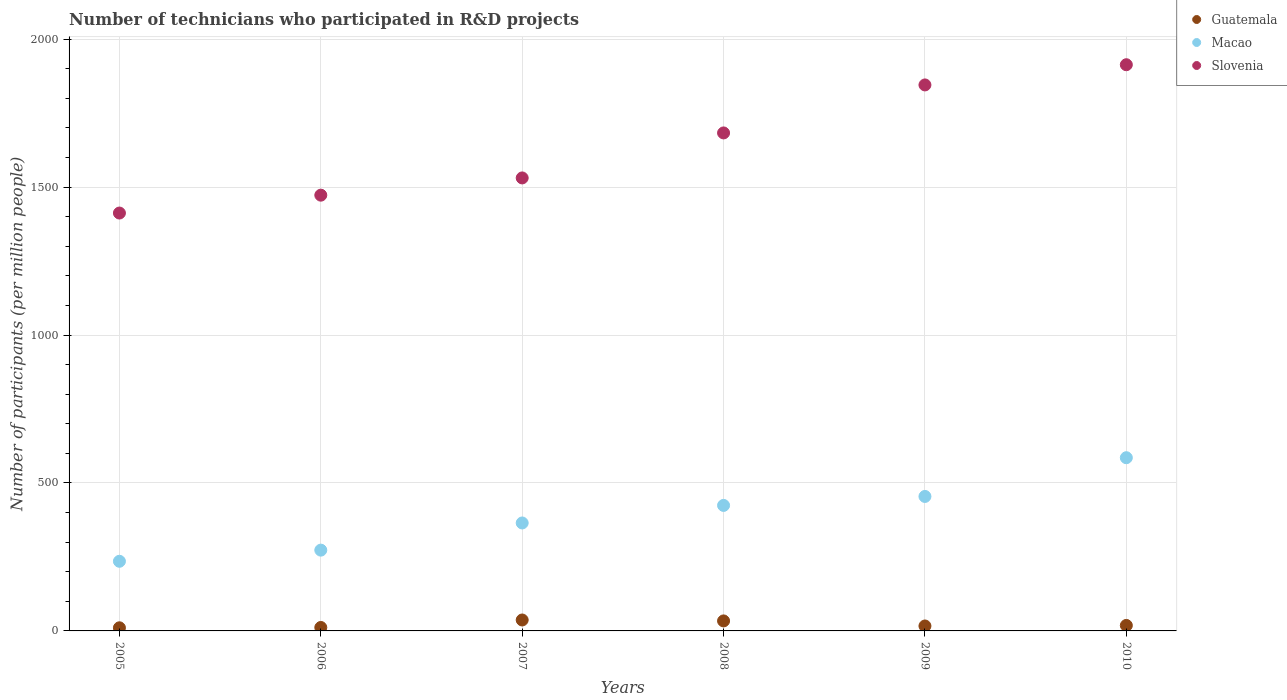What is the number of technicians who participated in R&D projects in Slovenia in 2006?
Provide a succinct answer. 1472.9. Across all years, what is the maximum number of technicians who participated in R&D projects in Macao?
Your response must be concise. 585.46. Across all years, what is the minimum number of technicians who participated in R&D projects in Slovenia?
Your answer should be very brief. 1412.46. In which year was the number of technicians who participated in R&D projects in Macao maximum?
Provide a short and direct response. 2010. In which year was the number of technicians who participated in R&D projects in Guatemala minimum?
Your answer should be compact. 2005. What is the total number of technicians who participated in R&D projects in Slovenia in the graph?
Provide a succinct answer. 9859.03. What is the difference between the number of technicians who participated in R&D projects in Guatemala in 2005 and that in 2010?
Offer a very short reply. -7.99. What is the difference between the number of technicians who participated in R&D projects in Guatemala in 2006 and the number of technicians who participated in R&D projects in Macao in 2009?
Make the answer very short. -442.9. What is the average number of technicians who participated in R&D projects in Macao per year?
Offer a terse response. 389.6. In the year 2010, what is the difference between the number of technicians who participated in R&D projects in Guatemala and number of technicians who participated in R&D projects in Slovenia?
Your response must be concise. -1895.25. What is the ratio of the number of technicians who participated in R&D projects in Macao in 2006 to that in 2010?
Your response must be concise. 0.47. What is the difference between the highest and the second highest number of technicians who participated in R&D projects in Slovenia?
Ensure brevity in your answer.  68.28. What is the difference between the highest and the lowest number of technicians who participated in R&D projects in Guatemala?
Your answer should be compact. 26.42. Is the sum of the number of technicians who participated in R&D projects in Macao in 2007 and 2010 greater than the maximum number of technicians who participated in R&D projects in Slovenia across all years?
Your response must be concise. No. Does the number of technicians who participated in R&D projects in Macao monotonically increase over the years?
Provide a succinct answer. Yes. Is the number of technicians who participated in R&D projects in Guatemala strictly greater than the number of technicians who participated in R&D projects in Macao over the years?
Offer a terse response. No. Is the number of technicians who participated in R&D projects in Slovenia strictly less than the number of technicians who participated in R&D projects in Macao over the years?
Make the answer very short. No. How many dotlines are there?
Ensure brevity in your answer.  3. Does the graph contain any zero values?
Keep it short and to the point. No. Does the graph contain grids?
Give a very brief answer. Yes. How many legend labels are there?
Your answer should be compact. 3. What is the title of the graph?
Provide a short and direct response. Number of technicians who participated in R&D projects. What is the label or title of the X-axis?
Offer a terse response. Years. What is the label or title of the Y-axis?
Offer a terse response. Number of participants (per million people). What is the Number of participants (per million people) in Guatemala in 2005?
Keep it short and to the point. 10.54. What is the Number of participants (per million people) in Macao in 2005?
Your answer should be very brief. 235.4. What is the Number of participants (per million people) in Slovenia in 2005?
Provide a short and direct response. 1412.46. What is the Number of participants (per million people) in Guatemala in 2006?
Give a very brief answer. 11.64. What is the Number of participants (per million people) of Macao in 2006?
Ensure brevity in your answer.  273.07. What is the Number of participants (per million people) in Slovenia in 2006?
Offer a terse response. 1472.9. What is the Number of participants (per million people) of Guatemala in 2007?
Offer a terse response. 36.96. What is the Number of participants (per million people) in Macao in 2007?
Offer a terse response. 364.89. What is the Number of participants (per million people) in Slovenia in 2007?
Your response must be concise. 1531.14. What is the Number of participants (per million people) of Guatemala in 2008?
Give a very brief answer. 33.81. What is the Number of participants (per million people) of Macao in 2008?
Your response must be concise. 424.23. What is the Number of participants (per million people) in Slovenia in 2008?
Keep it short and to the point. 1683.25. What is the Number of participants (per million people) of Guatemala in 2009?
Keep it short and to the point. 16.72. What is the Number of participants (per million people) of Macao in 2009?
Your response must be concise. 454.54. What is the Number of participants (per million people) of Slovenia in 2009?
Give a very brief answer. 1845.5. What is the Number of participants (per million people) of Guatemala in 2010?
Offer a very short reply. 18.53. What is the Number of participants (per million people) in Macao in 2010?
Make the answer very short. 585.46. What is the Number of participants (per million people) in Slovenia in 2010?
Your answer should be compact. 1913.78. Across all years, what is the maximum Number of participants (per million people) of Guatemala?
Offer a terse response. 36.96. Across all years, what is the maximum Number of participants (per million people) in Macao?
Provide a short and direct response. 585.46. Across all years, what is the maximum Number of participants (per million people) of Slovenia?
Your answer should be compact. 1913.78. Across all years, what is the minimum Number of participants (per million people) in Guatemala?
Give a very brief answer. 10.54. Across all years, what is the minimum Number of participants (per million people) of Macao?
Offer a terse response. 235.4. Across all years, what is the minimum Number of participants (per million people) of Slovenia?
Ensure brevity in your answer.  1412.46. What is the total Number of participants (per million people) of Guatemala in the graph?
Give a very brief answer. 128.2. What is the total Number of participants (per million people) in Macao in the graph?
Give a very brief answer. 2337.58. What is the total Number of participants (per million people) in Slovenia in the graph?
Your answer should be compact. 9859.03. What is the difference between the Number of participants (per million people) in Guatemala in 2005 and that in 2006?
Keep it short and to the point. -1.09. What is the difference between the Number of participants (per million people) in Macao in 2005 and that in 2006?
Your answer should be very brief. -37.68. What is the difference between the Number of participants (per million people) in Slovenia in 2005 and that in 2006?
Ensure brevity in your answer.  -60.44. What is the difference between the Number of participants (per million people) of Guatemala in 2005 and that in 2007?
Provide a succinct answer. -26.42. What is the difference between the Number of participants (per million people) of Macao in 2005 and that in 2007?
Your response must be concise. -129.5. What is the difference between the Number of participants (per million people) of Slovenia in 2005 and that in 2007?
Keep it short and to the point. -118.68. What is the difference between the Number of participants (per million people) in Guatemala in 2005 and that in 2008?
Offer a terse response. -23.27. What is the difference between the Number of participants (per million people) in Macao in 2005 and that in 2008?
Make the answer very short. -188.83. What is the difference between the Number of participants (per million people) of Slovenia in 2005 and that in 2008?
Give a very brief answer. -270.79. What is the difference between the Number of participants (per million people) of Guatemala in 2005 and that in 2009?
Offer a terse response. -6.17. What is the difference between the Number of participants (per million people) of Macao in 2005 and that in 2009?
Your answer should be compact. -219.15. What is the difference between the Number of participants (per million people) of Slovenia in 2005 and that in 2009?
Provide a succinct answer. -433.05. What is the difference between the Number of participants (per million people) of Guatemala in 2005 and that in 2010?
Provide a short and direct response. -7.99. What is the difference between the Number of participants (per million people) of Macao in 2005 and that in 2010?
Offer a very short reply. -350.06. What is the difference between the Number of participants (per million people) in Slovenia in 2005 and that in 2010?
Provide a succinct answer. -501.33. What is the difference between the Number of participants (per million people) of Guatemala in 2006 and that in 2007?
Your answer should be compact. -25.32. What is the difference between the Number of participants (per million people) in Macao in 2006 and that in 2007?
Ensure brevity in your answer.  -91.82. What is the difference between the Number of participants (per million people) in Slovenia in 2006 and that in 2007?
Give a very brief answer. -58.24. What is the difference between the Number of participants (per million people) of Guatemala in 2006 and that in 2008?
Your answer should be compact. -22.18. What is the difference between the Number of participants (per million people) of Macao in 2006 and that in 2008?
Give a very brief answer. -151.16. What is the difference between the Number of participants (per million people) in Slovenia in 2006 and that in 2008?
Your answer should be very brief. -210.35. What is the difference between the Number of participants (per million people) in Guatemala in 2006 and that in 2009?
Keep it short and to the point. -5.08. What is the difference between the Number of participants (per million people) in Macao in 2006 and that in 2009?
Offer a very short reply. -181.47. What is the difference between the Number of participants (per million people) of Slovenia in 2006 and that in 2009?
Offer a very short reply. -372.6. What is the difference between the Number of participants (per million people) in Guatemala in 2006 and that in 2010?
Your answer should be very brief. -6.89. What is the difference between the Number of participants (per million people) in Macao in 2006 and that in 2010?
Your answer should be very brief. -312.38. What is the difference between the Number of participants (per million people) in Slovenia in 2006 and that in 2010?
Give a very brief answer. -440.88. What is the difference between the Number of participants (per million people) of Guatemala in 2007 and that in 2008?
Keep it short and to the point. 3.15. What is the difference between the Number of participants (per million people) in Macao in 2007 and that in 2008?
Provide a succinct answer. -59.34. What is the difference between the Number of participants (per million people) of Slovenia in 2007 and that in 2008?
Your answer should be very brief. -152.11. What is the difference between the Number of participants (per million people) of Guatemala in 2007 and that in 2009?
Provide a succinct answer. 20.25. What is the difference between the Number of participants (per million people) of Macao in 2007 and that in 2009?
Keep it short and to the point. -89.65. What is the difference between the Number of participants (per million people) of Slovenia in 2007 and that in 2009?
Your response must be concise. -314.36. What is the difference between the Number of participants (per million people) in Guatemala in 2007 and that in 2010?
Keep it short and to the point. 18.43. What is the difference between the Number of participants (per million people) in Macao in 2007 and that in 2010?
Offer a terse response. -220.56. What is the difference between the Number of participants (per million people) of Slovenia in 2007 and that in 2010?
Provide a short and direct response. -382.64. What is the difference between the Number of participants (per million people) of Guatemala in 2008 and that in 2009?
Offer a terse response. 17.1. What is the difference between the Number of participants (per million people) in Macao in 2008 and that in 2009?
Give a very brief answer. -30.31. What is the difference between the Number of participants (per million people) in Slovenia in 2008 and that in 2009?
Provide a short and direct response. -162.26. What is the difference between the Number of participants (per million people) of Guatemala in 2008 and that in 2010?
Ensure brevity in your answer.  15.28. What is the difference between the Number of participants (per million people) of Macao in 2008 and that in 2010?
Your answer should be very brief. -161.23. What is the difference between the Number of participants (per million people) in Slovenia in 2008 and that in 2010?
Offer a terse response. -230.54. What is the difference between the Number of participants (per million people) in Guatemala in 2009 and that in 2010?
Offer a very short reply. -1.82. What is the difference between the Number of participants (per million people) of Macao in 2009 and that in 2010?
Your answer should be compact. -130.91. What is the difference between the Number of participants (per million people) of Slovenia in 2009 and that in 2010?
Give a very brief answer. -68.28. What is the difference between the Number of participants (per million people) of Guatemala in 2005 and the Number of participants (per million people) of Macao in 2006?
Provide a succinct answer. -262.53. What is the difference between the Number of participants (per million people) of Guatemala in 2005 and the Number of participants (per million people) of Slovenia in 2006?
Offer a terse response. -1462.36. What is the difference between the Number of participants (per million people) in Macao in 2005 and the Number of participants (per million people) in Slovenia in 2006?
Keep it short and to the point. -1237.51. What is the difference between the Number of participants (per million people) of Guatemala in 2005 and the Number of participants (per million people) of Macao in 2007?
Make the answer very short. -354.35. What is the difference between the Number of participants (per million people) of Guatemala in 2005 and the Number of participants (per million people) of Slovenia in 2007?
Your answer should be compact. -1520.6. What is the difference between the Number of participants (per million people) of Macao in 2005 and the Number of participants (per million people) of Slovenia in 2007?
Offer a terse response. -1295.74. What is the difference between the Number of participants (per million people) of Guatemala in 2005 and the Number of participants (per million people) of Macao in 2008?
Keep it short and to the point. -413.68. What is the difference between the Number of participants (per million people) of Guatemala in 2005 and the Number of participants (per million people) of Slovenia in 2008?
Ensure brevity in your answer.  -1672.7. What is the difference between the Number of participants (per million people) of Macao in 2005 and the Number of participants (per million people) of Slovenia in 2008?
Provide a short and direct response. -1447.85. What is the difference between the Number of participants (per million people) in Guatemala in 2005 and the Number of participants (per million people) in Macao in 2009?
Give a very brief answer. -444. What is the difference between the Number of participants (per million people) of Guatemala in 2005 and the Number of participants (per million people) of Slovenia in 2009?
Ensure brevity in your answer.  -1834.96. What is the difference between the Number of participants (per million people) in Macao in 2005 and the Number of participants (per million people) in Slovenia in 2009?
Your response must be concise. -1610.11. What is the difference between the Number of participants (per million people) in Guatemala in 2005 and the Number of participants (per million people) in Macao in 2010?
Ensure brevity in your answer.  -574.91. What is the difference between the Number of participants (per million people) in Guatemala in 2005 and the Number of participants (per million people) in Slovenia in 2010?
Provide a short and direct response. -1903.24. What is the difference between the Number of participants (per million people) in Macao in 2005 and the Number of participants (per million people) in Slovenia in 2010?
Offer a terse response. -1678.39. What is the difference between the Number of participants (per million people) in Guatemala in 2006 and the Number of participants (per million people) in Macao in 2007?
Your answer should be very brief. -353.25. What is the difference between the Number of participants (per million people) of Guatemala in 2006 and the Number of participants (per million people) of Slovenia in 2007?
Your response must be concise. -1519.5. What is the difference between the Number of participants (per million people) in Macao in 2006 and the Number of participants (per million people) in Slovenia in 2007?
Your answer should be compact. -1258.07. What is the difference between the Number of participants (per million people) in Guatemala in 2006 and the Number of participants (per million people) in Macao in 2008?
Provide a succinct answer. -412.59. What is the difference between the Number of participants (per million people) of Guatemala in 2006 and the Number of participants (per million people) of Slovenia in 2008?
Keep it short and to the point. -1671.61. What is the difference between the Number of participants (per million people) of Macao in 2006 and the Number of participants (per million people) of Slovenia in 2008?
Your answer should be compact. -1410.18. What is the difference between the Number of participants (per million people) of Guatemala in 2006 and the Number of participants (per million people) of Macao in 2009?
Make the answer very short. -442.9. What is the difference between the Number of participants (per million people) of Guatemala in 2006 and the Number of participants (per million people) of Slovenia in 2009?
Your answer should be compact. -1833.86. What is the difference between the Number of participants (per million people) of Macao in 2006 and the Number of participants (per million people) of Slovenia in 2009?
Offer a very short reply. -1572.43. What is the difference between the Number of participants (per million people) of Guatemala in 2006 and the Number of participants (per million people) of Macao in 2010?
Offer a very short reply. -573.82. What is the difference between the Number of participants (per million people) of Guatemala in 2006 and the Number of participants (per million people) of Slovenia in 2010?
Your answer should be very brief. -1902.14. What is the difference between the Number of participants (per million people) of Macao in 2006 and the Number of participants (per million people) of Slovenia in 2010?
Keep it short and to the point. -1640.71. What is the difference between the Number of participants (per million people) of Guatemala in 2007 and the Number of participants (per million people) of Macao in 2008?
Offer a very short reply. -387.27. What is the difference between the Number of participants (per million people) of Guatemala in 2007 and the Number of participants (per million people) of Slovenia in 2008?
Provide a short and direct response. -1646.28. What is the difference between the Number of participants (per million people) in Macao in 2007 and the Number of participants (per million people) in Slovenia in 2008?
Make the answer very short. -1318.35. What is the difference between the Number of participants (per million people) in Guatemala in 2007 and the Number of participants (per million people) in Macao in 2009?
Give a very brief answer. -417.58. What is the difference between the Number of participants (per million people) in Guatemala in 2007 and the Number of participants (per million people) in Slovenia in 2009?
Offer a terse response. -1808.54. What is the difference between the Number of participants (per million people) in Macao in 2007 and the Number of participants (per million people) in Slovenia in 2009?
Your answer should be very brief. -1480.61. What is the difference between the Number of participants (per million people) of Guatemala in 2007 and the Number of participants (per million people) of Macao in 2010?
Provide a succinct answer. -548.49. What is the difference between the Number of participants (per million people) of Guatemala in 2007 and the Number of participants (per million people) of Slovenia in 2010?
Offer a very short reply. -1876.82. What is the difference between the Number of participants (per million people) in Macao in 2007 and the Number of participants (per million people) in Slovenia in 2010?
Ensure brevity in your answer.  -1548.89. What is the difference between the Number of participants (per million people) in Guatemala in 2008 and the Number of participants (per million people) in Macao in 2009?
Offer a very short reply. -420.73. What is the difference between the Number of participants (per million people) of Guatemala in 2008 and the Number of participants (per million people) of Slovenia in 2009?
Your response must be concise. -1811.69. What is the difference between the Number of participants (per million people) of Macao in 2008 and the Number of participants (per million people) of Slovenia in 2009?
Your response must be concise. -1421.27. What is the difference between the Number of participants (per million people) in Guatemala in 2008 and the Number of participants (per million people) in Macao in 2010?
Ensure brevity in your answer.  -551.64. What is the difference between the Number of participants (per million people) in Guatemala in 2008 and the Number of participants (per million people) in Slovenia in 2010?
Your response must be concise. -1879.97. What is the difference between the Number of participants (per million people) in Macao in 2008 and the Number of participants (per million people) in Slovenia in 2010?
Ensure brevity in your answer.  -1489.55. What is the difference between the Number of participants (per million people) in Guatemala in 2009 and the Number of participants (per million people) in Macao in 2010?
Your response must be concise. -568.74. What is the difference between the Number of participants (per million people) in Guatemala in 2009 and the Number of participants (per million people) in Slovenia in 2010?
Make the answer very short. -1897.07. What is the difference between the Number of participants (per million people) of Macao in 2009 and the Number of participants (per million people) of Slovenia in 2010?
Your answer should be compact. -1459.24. What is the average Number of participants (per million people) in Guatemala per year?
Your response must be concise. 21.37. What is the average Number of participants (per million people) in Macao per year?
Your answer should be compact. 389.6. What is the average Number of participants (per million people) in Slovenia per year?
Keep it short and to the point. 1643.17. In the year 2005, what is the difference between the Number of participants (per million people) in Guatemala and Number of participants (per million people) in Macao?
Your answer should be very brief. -224.85. In the year 2005, what is the difference between the Number of participants (per million people) in Guatemala and Number of participants (per million people) in Slovenia?
Make the answer very short. -1401.91. In the year 2005, what is the difference between the Number of participants (per million people) in Macao and Number of participants (per million people) in Slovenia?
Offer a very short reply. -1177.06. In the year 2006, what is the difference between the Number of participants (per million people) in Guatemala and Number of participants (per million people) in Macao?
Keep it short and to the point. -261.43. In the year 2006, what is the difference between the Number of participants (per million people) in Guatemala and Number of participants (per million people) in Slovenia?
Your response must be concise. -1461.26. In the year 2006, what is the difference between the Number of participants (per million people) of Macao and Number of participants (per million people) of Slovenia?
Ensure brevity in your answer.  -1199.83. In the year 2007, what is the difference between the Number of participants (per million people) of Guatemala and Number of participants (per million people) of Macao?
Make the answer very short. -327.93. In the year 2007, what is the difference between the Number of participants (per million people) in Guatemala and Number of participants (per million people) in Slovenia?
Offer a terse response. -1494.18. In the year 2007, what is the difference between the Number of participants (per million people) of Macao and Number of participants (per million people) of Slovenia?
Make the answer very short. -1166.25. In the year 2008, what is the difference between the Number of participants (per million people) in Guatemala and Number of participants (per million people) in Macao?
Offer a terse response. -390.41. In the year 2008, what is the difference between the Number of participants (per million people) of Guatemala and Number of participants (per million people) of Slovenia?
Offer a terse response. -1649.43. In the year 2008, what is the difference between the Number of participants (per million people) of Macao and Number of participants (per million people) of Slovenia?
Give a very brief answer. -1259.02. In the year 2009, what is the difference between the Number of participants (per million people) of Guatemala and Number of participants (per million people) of Macao?
Offer a terse response. -437.83. In the year 2009, what is the difference between the Number of participants (per million people) in Guatemala and Number of participants (per million people) in Slovenia?
Offer a terse response. -1828.79. In the year 2009, what is the difference between the Number of participants (per million people) in Macao and Number of participants (per million people) in Slovenia?
Offer a very short reply. -1390.96. In the year 2010, what is the difference between the Number of participants (per million people) in Guatemala and Number of participants (per million people) in Macao?
Offer a terse response. -566.93. In the year 2010, what is the difference between the Number of participants (per million people) in Guatemala and Number of participants (per million people) in Slovenia?
Your answer should be compact. -1895.25. In the year 2010, what is the difference between the Number of participants (per million people) of Macao and Number of participants (per million people) of Slovenia?
Your response must be concise. -1328.33. What is the ratio of the Number of participants (per million people) of Guatemala in 2005 to that in 2006?
Your response must be concise. 0.91. What is the ratio of the Number of participants (per million people) of Macao in 2005 to that in 2006?
Offer a very short reply. 0.86. What is the ratio of the Number of participants (per million people) of Guatemala in 2005 to that in 2007?
Give a very brief answer. 0.29. What is the ratio of the Number of participants (per million people) of Macao in 2005 to that in 2007?
Provide a short and direct response. 0.65. What is the ratio of the Number of participants (per million people) in Slovenia in 2005 to that in 2007?
Ensure brevity in your answer.  0.92. What is the ratio of the Number of participants (per million people) in Guatemala in 2005 to that in 2008?
Make the answer very short. 0.31. What is the ratio of the Number of participants (per million people) in Macao in 2005 to that in 2008?
Ensure brevity in your answer.  0.55. What is the ratio of the Number of participants (per million people) in Slovenia in 2005 to that in 2008?
Ensure brevity in your answer.  0.84. What is the ratio of the Number of participants (per million people) of Guatemala in 2005 to that in 2009?
Offer a terse response. 0.63. What is the ratio of the Number of participants (per million people) in Macao in 2005 to that in 2009?
Your response must be concise. 0.52. What is the ratio of the Number of participants (per million people) of Slovenia in 2005 to that in 2009?
Your answer should be compact. 0.77. What is the ratio of the Number of participants (per million people) in Guatemala in 2005 to that in 2010?
Your response must be concise. 0.57. What is the ratio of the Number of participants (per million people) in Macao in 2005 to that in 2010?
Make the answer very short. 0.4. What is the ratio of the Number of participants (per million people) in Slovenia in 2005 to that in 2010?
Make the answer very short. 0.74. What is the ratio of the Number of participants (per million people) in Guatemala in 2006 to that in 2007?
Provide a short and direct response. 0.31. What is the ratio of the Number of participants (per million people) of Macao in 2006 to that in 2007?
Offer a very short reply. 0.75. What is the ratio of the Number of participants (per million people) of Guatemala in 2006 to that in 2008?
Ensure brevity in your answer.  0.34. What is the ratio of the Number of participants (per million people) of Macao in 2006 to that in 2008?
Keep it short and to the point. 0.64. What is the ratio of the Number of participants (per million people) in Guatemala in 2006 to that in 2009?
Your answer should be very brief. 0.7. What is the ratio of the Number of participants (per million people) of Macao in 2006 to that in 2009?
Your response must be concise. 0.6. What is the ratio of the Number of participants (per million people) of Slovenia in 2006 to that in 2009?
Offer a terse response. 0.8. What is the ratio of the Number of participants (per million people) in Guatemala in 2006 to that in 2010?
Your answer should be very brief. 0.63. What is the ratio of the Number of participants (per million people) in Macao in 2006 to that in 2010?
Your answer should be very brief. 0.47. What is the ratio of the Number of participants (per million people) in Slovenia in 2006 to that in 2010?
Offer a very short reply. 0.77. What is the ratio of the Number of participants (per million people) in Guatemala in 2007 to that in 2008?
Your answer should be compact. 1.09. What is the ratio of the Number of participants (per million people) of Macao in 2007 to that in 2008?
Give a very brief answer. 0.86. What is the ratio of the Number of participants (per million people) of Slovenia in 2007 to that in 2008?
Your answer should be very brief. 0.91. What is the ratio of the Number of participants (per million people) in Guatemala in 2007 to that in 2009?
Provide a succinct answer. 2.21. What is the ratio of the Number of participants (per million people) in Macao in 2007 to that in 2009?
Your answer should be compact. 0.8. What is the ratio of the Number of participants (per million people) in Slovenia in 2007 to that in 2009?
Make the answer very short. 0.83. What is the ratio of the Number of participants (per million people) in Guatemala in 2007 to that in 2010?
Your response must be concise. 1.99. What is the ratio of the Number of participants (per million people) of Macao in 2007 to that in 2010?
Make the answer very short. 0.62. What is the ratio of the Number of participants (per million people) of Slovenia in 2007 to that in 2010?
Ensure brevity in your answer.  0.8. What is the ratio of the Number of participants (per million people) of Guatemala in 2008 to that in 2009?
Keep it short and to the point. 2.02. What is the ratio of the Number of participants (per million people) of Macao in 2008 to that in 2009?
Ensure brevity in your answer.  0.93. What is the ratio of the Number of participants (per million people) in Slovenia in 2008 to that in 2009?
Offer a very short reply. 0.91. What is the ratio of the Number of participants (per million people) in Guatemala in 2008 to that in 2010?
Offer a very short reply. 1.82. What is the ratio of the Number of participants (per million people) of Macao in 2008 to that in 2010?
Give a very brief answer. 0.72. What is the ratio of the Number of participants (per million people) of Slovenia in 2008 to that in 2010?
Ensure brevity in your answer.  0.88. What is the ratio of the Number of participants (per million people) of Guatemala in 2009 to that in 2010?
Give a very brief answer. 0.9. What is the ratio of the Number of participants (per million people) of Macao in 2009 to that in 2010?
Offer a very short reply. 0.78. What is the difference between the highest and the second highest Number of participants (per million people) of Guatemala?
Give a very brief answer. 3.15. What is the difference between the highest and the second highest Number of participants (per million people) of Macao?
Your answer should be compact. 130.91. What is the difference between the highest and the second highest Number of participants (per million people) in Slovenia?
Provide a succinct answer. 68.28. What is the difference between the highest and the lowest Number of participants (per million people) in Guatemala?
Provide a succinct answer. 26.42. What is the difference between the highest and the lowest Number of participants (per million people) in Macao?
Provide a succinct answer. 350.06. What is the difference between the highest and the lowest Number of participants (per million people) of Slovenia?
Your response must be concise. 501.33. 